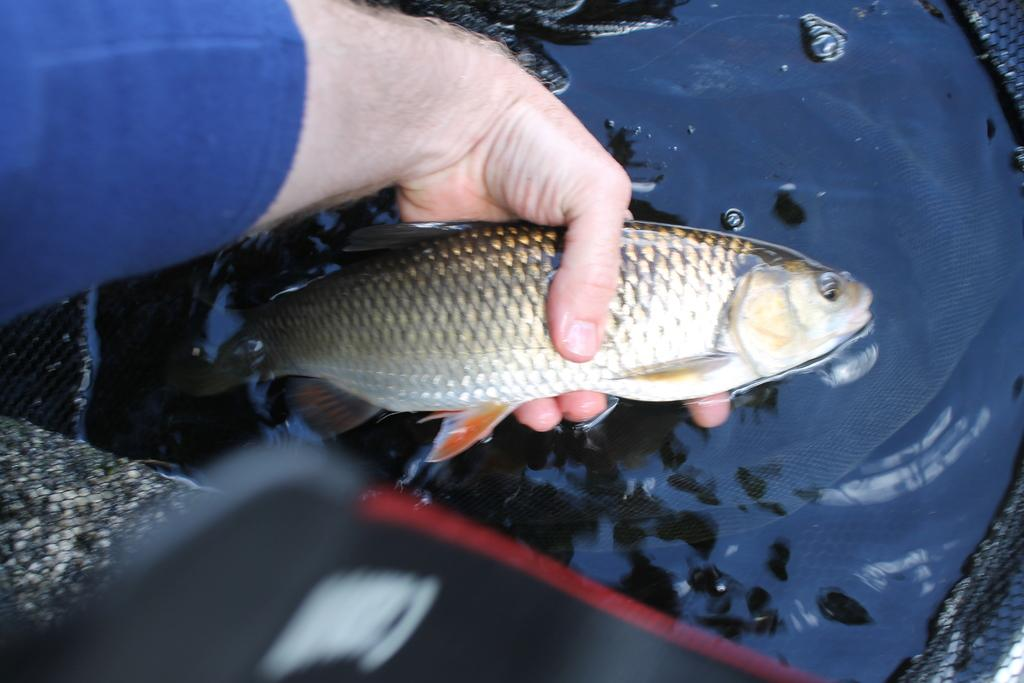What is the person's hand holding in the image? The person's hand is holding a fish in the image. What is the surrounding environment like in the image? There is water visible in the image. What tool is present in the image? There is a net in the image. What kind of trouble is the fish causing in the image? There is no indication of trouble in the image; the person's hand is simply holding the fish. 